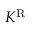<formula> <loc_0><loc_0><loc_500><loc_500>K ^ { R }</formula> 